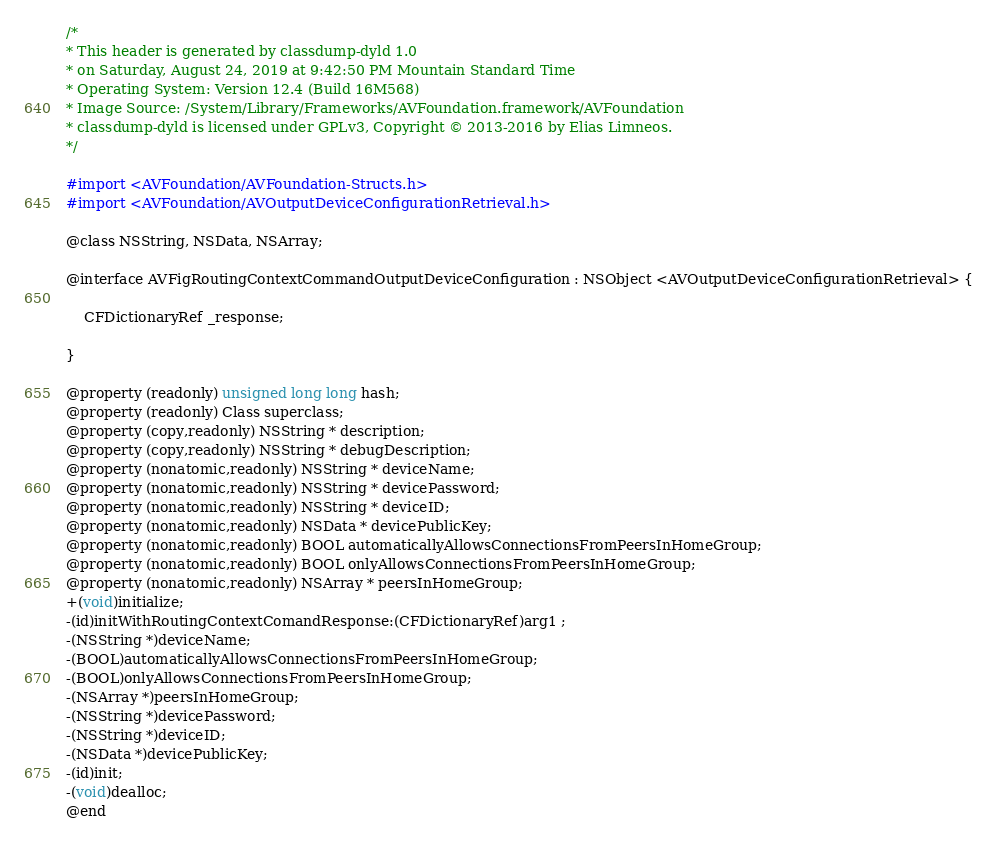Convert code to text. <code><loc_0><loc_0><loc_500><loc_500><_C_>/*
* This header is generated by classdump-dyld 1.0
* on Saturday, August 24, 2019 at 9:42:50 PM Mountain Standard Time
* Operating System: Version 12.4 (Build 16M568)
* Image Source: /System/Library/Frameworks/AVFoundation.framework/AVFoundation
* classdump-dyld is licensed under GPLv3, Copyright © 2013-2016 by Elias Limneos.
*/

#import <AVFoundation/AVFoundation-Structs.h>
#import <AVFoundation/AVOutputDeviceConfigurationRetrieval.h>

@class NSString, NSData, NSArray;

@interface AVFigRoutingContextCommandOutputDeviceConfiguration : NSObject <AVOutputDeviceConfigurationRetrieval> {

	CFDictionaryRef _response;

}

@property (readonly) unsigned long long hash; 
@property (readonly) Class superclass; 
@property (copy,readonly) NSString * description; 
@property (copy,readonly) NSString * debugDescription; 
@property (nonatomic,readonly) NSString * deviceName; 
@property (nonatomic,readonly) NSString * devicePassword; 
@property (nonatomic,readonly) NSString * deviceID; 
@property (nonatomic,readonly) NSData * devicePublicKey; 
@property (nonatomic,readonly) BOOL automaticallyAllowsConnectionsFromPeersInHomeGroup; 
@property (nonatomic,readonly) BOOL onlyAllowsConnectionsFromPeersInHomeGroup; 
@property (nonatomic,readonly) NSArray * peersInHomeGroup; 
+(void)initialize;
-(id)initWithRoutingContextComandResponse:(CFDictionaryRef)arg1 ;
-(NSString *)deviceName;
-(BOOL)automaticallyAllowsConnectionsFromPeersInHomeGroup;
-(BOOL)onlyAllowsConnectionsFromPeersInHomeGroup;
-(NSArray *)peersInHomeGroup;
-(NSString *)devicePassword;
-(NSString *)deviceID;
-(NSData *)devicePublicKey;
-(id)init;
-(void)dealloc;
@end

</code> 